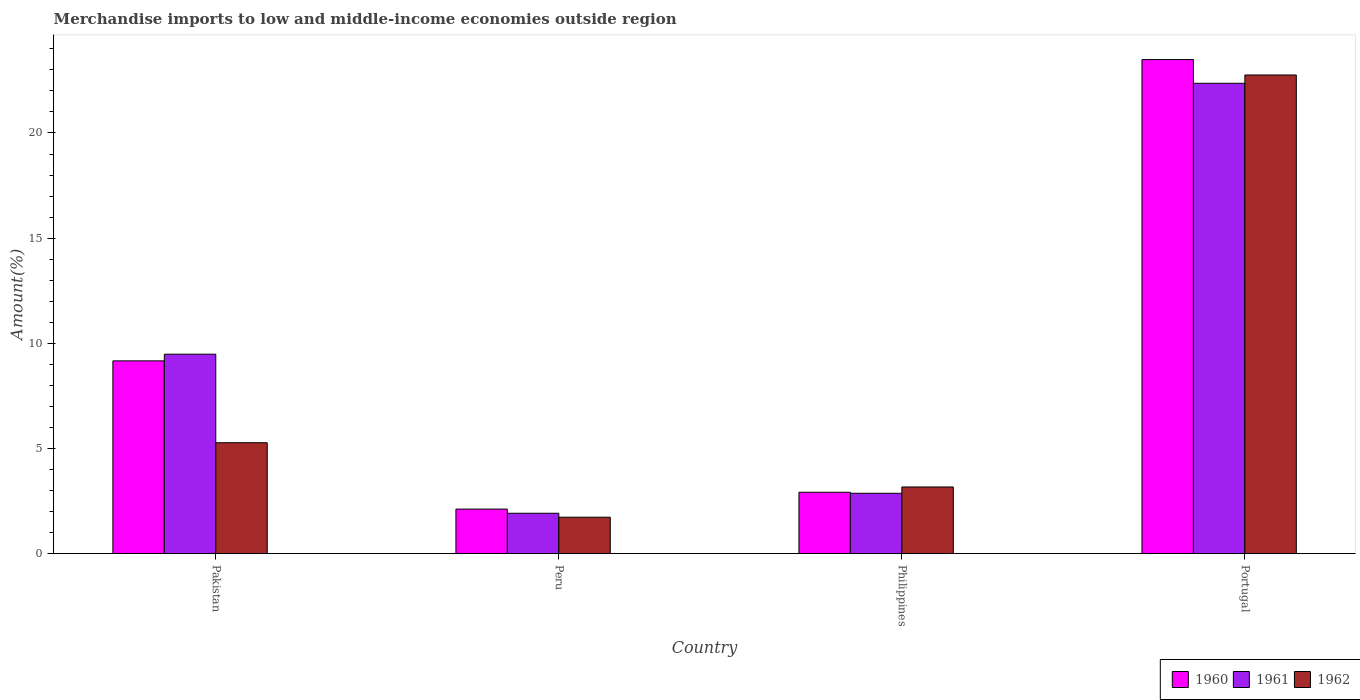How many different coloured bars are there?
Provide a short and direct response. 3. Are the number of bars on each tick of the X-axis equal?
Keep it short and to the point. Yes. What is the label of the 3rd group of bars from the left?
Ensure brevity in your answer.  Philippines. In how many cases, is the number of bars for a given country not equal to the number of legend labels?
Give a very brief answer. 0. What is the percentage of amount earned from merchandise imports in 1961 in Pakistan?
Your answer should be compact. 9.48. Across all countries, what is the maximum percentage of amount earned from merchandise imports in 1962?
Keep it short and to the point. 22.76. Across all countries, what is the minimum percentage of amount earned from merchandise imports in 1961?
Give a very brief answer. 1.92. In which country was the percentage of amount earned from merchandise imports in 1962 maximum?
Provide a short and direct response. Portugal. In which country was the percentage of amount earned from merchandise imports in 1960 minimum?
Keep it short and to the point. Peru. What is the total percentage of amount earned from merchandise imports in 1961 in the graph?
Give a very brief answer. 36.63. What is the difference between the percentage of amount earned from merchandise imports in 1962 in Philippines and that in Portugal?
Keep it short and to the point. -19.59. What is the difference between the percentage of amount earned from merchandise imports in 1962 in Peru and the percentage of amount earned from merchandise imports in 1961 in Portugal?
Your response must be concise. -20.63. What is the average percentage of amount earned from merchandise imports in 1962 per country?
Provide a succinct answer. 8.23. What is the difference between the percentage of amount earned from merchandise imports of/in 1962 and percentage of amount earned from merchandise imports of/in 1960 in Portugal?
Your answer should be compact. -0.73. What is the ratio of the percentage of amount earned from merchandise imports in 1960 in Pakistan to that in Philippines?
Offer a terse response. 3.14. Is the percentage of amount earned from merchandise imports in 1960 in Pakistan less than that in Peru?
Your answer should be very brief. No. Is the difference between the percentage of amount earned from merchandise imports in 1962 in Peru and Philippines greater than the difference between the percentage of amount earned from merchandise imports in 1960 in Peru and Philippines?
Give a very brief answer. No. What is the difference between the highest and the second highest percentage of amount earned from merchandise imports in 1960?
Your answer should be compact. 6.25. What is the difference between the highest and the lowest percentage of amount earned from merchandise imports in 1962?
Keep it short and to the point. 21.02. In how many countries, is the percentage of amount earned from merchandise imports in 1961 greater than the average percentage of amount earned from merchandise imports in 1961 taken over all countries?
Your answer should be compact. 2. What does the 2nd bar from the left in Peru represents?
Keep it short and to the point. 1961. What does the 2nd bar from the right in Peru represents?
Offer a terse response. 1961. Is it the case that in every country, the sum of the percentage of amount earned from merchandise imports in 1960 and percentage of amount earned from merchandise imports in 1961 is greater than the percentage of amount earned from merchandise imports in 1962?
Ensure brevity in your answer.  Yes. How many bars are there?
Provide a short and direct response. 12. Are all the bars in the graph horizontal?
Offer a very short reply. No. How many countries are there in the graph?
Offer a very short reply. 4. Where does the legend appear in the graph?
Your answer should be compact. Bottom right. What is the title of the graph?
Your response must be concise. Merchandise imports to low and middle-income economies outside region. Does "2013" appear as one of the legend labels in the graph?
Your answer should be compact. No. What is the label or title of the X-axis?
Your answer should be very brief. Country. What is the label or title of the Y-axis?
Provide a short and direct response. Amount(%). What is the Amount(%) of 1960 in Pakistan?
Keep it short and to the point. 9.17. What is the Amount(%) in 1961 in Pakistan?
Offer a very short reply. 9.48. What is the Amount(%) of 1962 in Pakistan?
Offer a very short reply. 5.27. What is the Amount(%) in 1960 in Peru?
Give a very brief answer. 2.12. What is the Amount(%) of 1961 in Peru?
Provide a succinct answer. 1.92. What is the Amount(%) in 1962 in Peru?
Offer a very short reply. 1.73. What is the Amount(%) in 1960 in Philippines?
Your response must be concise. 2.92. What is the Amount(%) in 1961 in Philippines?
Provide a succinct answer. 2.87. What is the Amount(%) of 1962 in Philippines?
Provide a short and direct response. 3.17. What is the Amount(%) of 1960 in Portugal?
Your response must be concise. 23.49. What is the Amount(%) in 1961 in Portugal?
Make the answer very short. 22.36. What is the Amount(%) in 1962 in Portugal?
Offer a very short reply. 22.76. Across all countries, what is the maximum Amount(%) in 1960?
Your response must be concise. 23.49. Across all countries, what is the maximum Amount(%) of 1961?
Provide a succinct answer. 22.36. Across all countries, what is the maximum Amount(%) in 1962?
Your response must be concise. 22.76. Across all countries, what is the minimum Amount(%) of 1960?
Offer a very short reply. 2.12. Across all countries, what is the minimum Amount(%) in 1961?
Provide a short and direct response. 1.92. Across all countries, what is the minimum Amount(%) in 1962?
Provide a succinct answer. 1.73. What is the total Amount(%) of 1960 in the graph?
Offer a terse response. 37.69. What is the total Amount(%) in 1961 in the graph?
Offer a terse response. 36.63. What is the total Amount(%) in 1962 in the graph?
Keep it short and to the point. 32.93. What is the difference between the Amount(%) in 1960 in Pakistan and that in Peru?
Make the answer very short. 7.05. What is the difference between the Amount(%) in 1961 in Pakistan and that in Peru?
Give a very brief answer. 7.56. What is the difference between the Amount(%) of 1962 in Pakistan and that in Peru?
Offer a very short reply. 3.54. What is the difference between the Amount(%) of 1960 in Pakistan and that in Philippines?
Offer a very short reply. 6.25. What is the difference between the Amount(%) in 1961 in Pakistan and that in Philippines?
Provide a short and direct response. 6.61. What is the difference between the Amount(%) in 1962 in Pakistan and that in Philippines?
Give a very brief answer. 2.1. What is the difference between the Amount(%) of 1960 in Pakistan and that in Portugal?
Your answer should be very brief. -14.32. What is the difference between the Amount(%) of 1961 in Pakistan and that in Portugal?
Offer a very short reply. -12.88. What is the difference between the Amount(%) in 1962 in Pakistan and that in Portugal?
Your answer should be compact. -17.48. What is the difference between the Amount(%) of 1960 in Peru and that in Philippines?
Your response must be concise. -0.8. What is the difference between the Amount(%) in 1961 in Peru and that in Philippines?
Your response must be concise. -0.95. What is the difference between the Amount(%) of 1962 in Peru and that in Philippines?
Your response must be concise. -1.44. What is the difference between the Amount(%) of 1960 in Peru and that in Portugal?
Offer a terse response. -21.37. What is the difference between the Amount(%) in 1961 in Peru and that in Portugal?
Keep it short and to the point. -20.44. What is the difference between the Amount(%) in 1962 in Peru and that in Portugal?
Offer a terse response. -21.02. What is the difference between the Amount(%) of 1960 in Philippines and that in Portugal?
Keep it short and to the point. -20.57. What is the difference between the Amount(%) in 1961 in Philippines and that in Portugal?
Your answer should be compact. -19.49. What is the difference between the Amount(%) in 1962 in Philippines and that in Portugal?
Ensure brevity in your answer.  -19.59. What is the difference between the Amount(%) of 1960 in Pakistan and the Amount(%) of 1961 in Peru?
Offer a terse response. 7.25. What is the difference between the Amount(%) in 1960 in Pakistan and the Amount(%) in 1962 in Peru?
Ensure brevity in your answer.  7.43. What is the difference between the Amount(%) of 1961 in Pakistan and the Amount(%) of 1962 in Peru?
Ensure brevity in your answer.  7.75. What is the difference between the Amount(%) in 1960 in Pakistan and the Amount(%) in 1961 in Philippines?
Give a very brief answer. 6.3. What is the difference between the Amount(%) in 1960 in Pakistan and the Amount(%) in 1962 in Philippines?
Offer a terse response. 6. What is the difference between the Amount(%) in 1961 in Pakistan and the Amount(%) in 1962 in Philippines?
Your answer should be compact. 6.31. What is the difference between the Amount(%) of 1960 in Pakistan and the Amount(%) of 1961 in Portugal?
Give a very brief answer. -13.2. What is the difference between the Amount(%) in 1960 in Pakistan and the Amount(%) in 1962 in Portugal?
Provide a short and direct response. -13.59. What is the difference between the Amount(%) of 1961 in Pakistan and the Amount(%) of 1962 in Portugal?
Ensure brevity in your answer.  -13.27. What is the difference between the Amount(%) in 1960 in Peru and the Amount(%) in 1961 in Philippines?
Provide a succinct answer. -0.75. What is the difference between the Amount(%) of 1960 in Peru and the Amount(%) of 1962 in Philippines?
Ensure brevity in your answer.  -1.05. What is the difference between the Amount(%) of 1961 in Peru and the Amount(%) of 1962 in Philippines?
Offer a very short reply. -1.25. What is the difference between the Amount(%) of 1960 in Peru and the Amount(%) of 1961 in Portugal?
Your answer should be compact. -20.24. What is the difference between the Amount(%) in 1960 in Peru and the Amount(%) in 1962 in Portugal?
Your answer should be compact. -20.64. What is the difference between the Amount(%) in 1961 in Peru and the Amount(%) in 1962 in Portugal?
Ensure brevity in your answer.  -20.84. What is the difference between the Amount(%) of 1960 in Philippines and the Amount(%) of 1961 in Portugal?
Provide a short and direct response. -19.44. What is the difference between the Amount(%) in 1960 in Philippines and the Amount(%) in 1962 in Portugal?
Give a very brief answer. -19.84. What is the difference between the Amount(%) in 1961 in Philippines and the Amount(%) in 1962 in Portugal?
Ensure brevity in your answer.  -19.89. What is the average Amount(%) in 1960 per country?
Offer a terse response. 9.42. What is the average Amount(%) of 1961 per country?
Give a very brief answer. 9.16. What is the average Amount(%) of 1962 per country?
Offer a terse response. 8.23. What is the difference between the Amount(%) of 1960 and Amount(%) of 1961 in Pakistan?
Provide a short and direct response. -0.32. What is the difference between the Amount(%) in 1960 and Amount(%) in 1962 in Pakistan?
Keep it short and to the point. 3.89. What is the difference between the Amount(%) in 1961 and Amount(%) in 1962 in Pakistan?
Keep it short and to the point. 4.21. What is the difference between the Amount(%) in 1960 and Amount(%) in 1961 in Peru?
Your answer should be compact. 0.2. What is the difference between the Amount(%) in 1960 and Amount(%) in 1962 in Peru?
Give a very brief answer. 0.39. What is the difference between the Amount(%) in 1961 and Amount(%) in 1962 in Peru?
Offer a very short reply. 0.19. What is the difference between the Amount(%) in 1960 and Amount(%) in 1961 in Philippines?
Offer a very short reply. 0.05. What is the difference between the Amount(%) of 1960 and Amount(%) of 1962 in Philippines?
Offer a terse response. -0.25. What is the difference between the Amount(%) in 1961 and Amount(%) in 1962 in Philippines?
Your answer should be compact. -0.3. What is the difference between the Amount(%) in 1960 and Amount(%) in 1961 in Portugal?
Make the answer very short. 1.13. What is the difference between the Amount(%) in 1960 and Amount(%) in 1962 in Portugal?
Provide a succinct answer. 0.73. What is the difference between the Amount(%) in 1961 and Amount(%) in 1962 in Portugal?
Offer a terse response. -0.39. What is the ratio of the Amount(%) in 1960 in Pakistan to that in Peru?
Provide a succinct answer. 4.33. What is the ratio of the Amount(%) of 1961 in Pakistan to that in Peru?
Give a very brief answer. 4.94. What is the ratio of the Amount(%) of 1962 in Pakistan to that in Peru?
Your answer should be very brief. 3.04. What is the ratio of the Amount(%) in 1960 in Pakistan to that in Philippines?
Provide a succinct answer. 3.14. What is the ratio of the Amount(%) of 1961 in Pakistan to that in Philippines?
Ensure brevity in your answer.  3.3. What is the ratio of the Amount(%) of 1962 in Pakistan to that in Philippines?
Your response must be concise. 1.66. What is the ratio of the Amount(%) of 1960 in Pakistan to that in Portugal?
Your answer should be very brief. 0.39. What is the ratio of the Amount(%) in 1961 in Pakistan to that in Portugal?
Provide a succinct answer. 0.42. What is the ratio of the Amount(%) in 1962 in Pakistan to that in Portugal?
Offer a terse response. 0.23. What is the ratio of the Amount(%) of 1960 in Peru to that in Philippines?
Your answer should be compact. 0.73. What is the ratio of the Amount(%) of 1961 in Peru to that in Philippines?
Provide a succinct answer. 0.67. What is the ratio of the Amount(%) of 1962 in Peru to that in Philippines?
Make the answer very short. 0.55. What is the ratio of the Amount(%) in 1960 in Peru to that in Portugal?
Ensure brevity in your answer.  0.09. What is the ratio of the Amount(%) in 1961 in Peru to that in Portugal?
Provide a succinct answer. 0.09. What is the ratio of the Amount(%) in 1962 in Peru to that in Portugal?
Provide a succinct answer. 0.08. What is the ratio of the Amount(%) in 1960 in Philippines to that in Portugal?
Make the answer very short. 0.12. What is the ratio of the Amount(%) in 1961 in Philippines to that in Portugal?
Give a very brief answer. 0.13. What is the ratio of the Amount(%) of 1962 in Philippines to that in Portugal?
Ensure brevity in your answer.  0.14. What is the difference between the highest and the second highest Amount(%) in 1960?
Give a very brief answer. 14.32. What is the difference between the highest and the second highest Amount(%) in 1961?
Give a very brief answer. 12.88. What is the difference between the highest and the second highest Amount(%) in 1962?
Give a very brief answer. 17.48. What is the difference between the highest and the lowest Amount(%) of 1960?
Offer a very short reply. 21.37. What is the difference between the highest and the lowest Amount(%) of 1961?
Your answer should be compact. 20.44. What is the difference between the highest and the lowest Amount(%) of 1962?
Offer a very short reply. 21.02. 